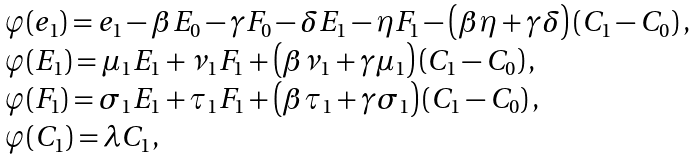Convert formula to latex. <formula><loc_0><loc_0><loc_500><loc_500>\begin{array} [ t ] { l } \varphi ( e _ { 1 } ) = e _ { 1 } - \beta E _ { 0 } - \gamma F _ { 0 } - \delta E _ { 1 } - \eta F _ { 1 } - \left ( \beta \eta + \gamma \delta \right ) \left ( C _ { 1 } - C _ { 0 } \right ) , \\ \varphi ( E _ { 1 } ) = \mu _ { 1 } E _ { 1 } + \nu _ { 1 } F _ { 1 } + \left ( \beta \nu _ { 1 } + \gamma \mu _ { 1 } \right ) \left ( C _ { 1 } - C _ { 0 } \right ) , \\ \varphi ( F _ { 1 } ) = \sigma _ { 1 } E _ { 1 } + \tau _ { 1 } F _ { 1 } + \left ( \beta \tau _ { 1 } + \gamma \sigma _ { 1 } \right ) \left ( C _ { 1 } - C _ { 0 } \right ) , \\ \varphi ( C _ { 1 } ) = \lambda C _ { 1 } , \end{array}</formula> 